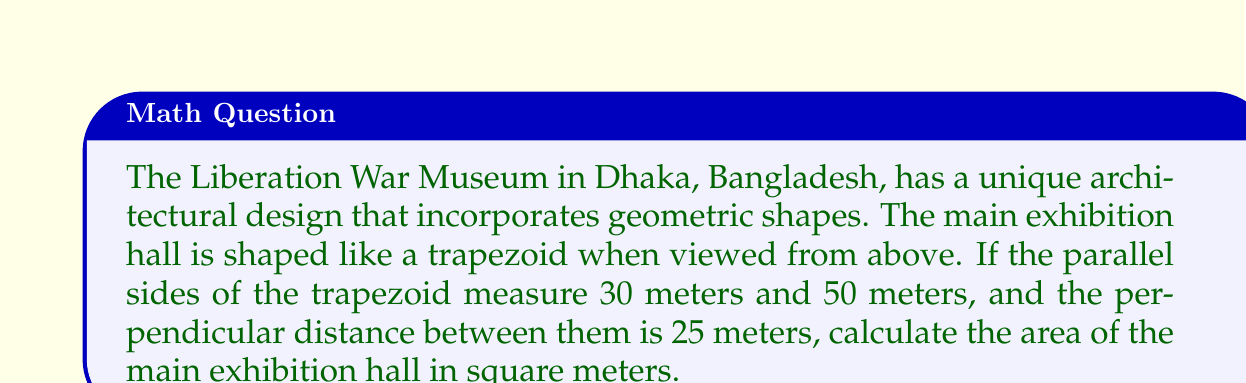Help me with this question. To calculate the area of the trapezoidal exhibition hall, we'll use the formula for the area of a trapezoid:

$$A = \frac{1}{2}(a+b)h$$

Where:
$A$ = Area of the trapezoid
$a$ and $b$ = Lengths of the parallel sides
$h$ = Height (perpendicular distance between parallel sides)

Given:
$a = 30$ meters
$b = 50$ meters
$h = 25$ meters

Let's substitute these values into the formula:

$$A = \frac{1}{2}(30+50) \cdot 25$$

Simplifying:
$$A = \frac{1}{2}(80) \cdot 25$$
$$A = 40 \cdot 25$$
$$A = 1000$$

Therefore, the area of the main exhibition hall is 1000 square meters.

[asy]
unitsize(4mm);
pair A = (0,0), B = (10,0), C = (7,5), D = (-3,5);
draw(A--B--C--D--cycle);
label("30m", (D+A)/2, W);
label("50m", (B+C)/2, E);
label("25m", (A+D)/2, W);
draw((-3,0)--(7,0), dashed);
[/asy]
Answer: 1000 m² 